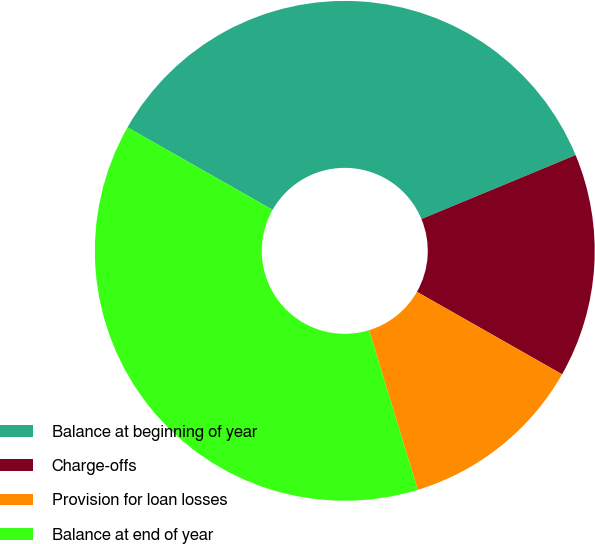Convert chart to OTSL. <chart><loc_0><loc_0><loc_500><loc_500><pie_chart><fcel>Balance at beginning of year<fcel>Charge-offs<fcel>Provision for loan losses<fcel>Balance at end of year<nl><fcel>35.52%<fcel>14.48%<fcel>12.06%<fcel>37.94%<nl></chart> 